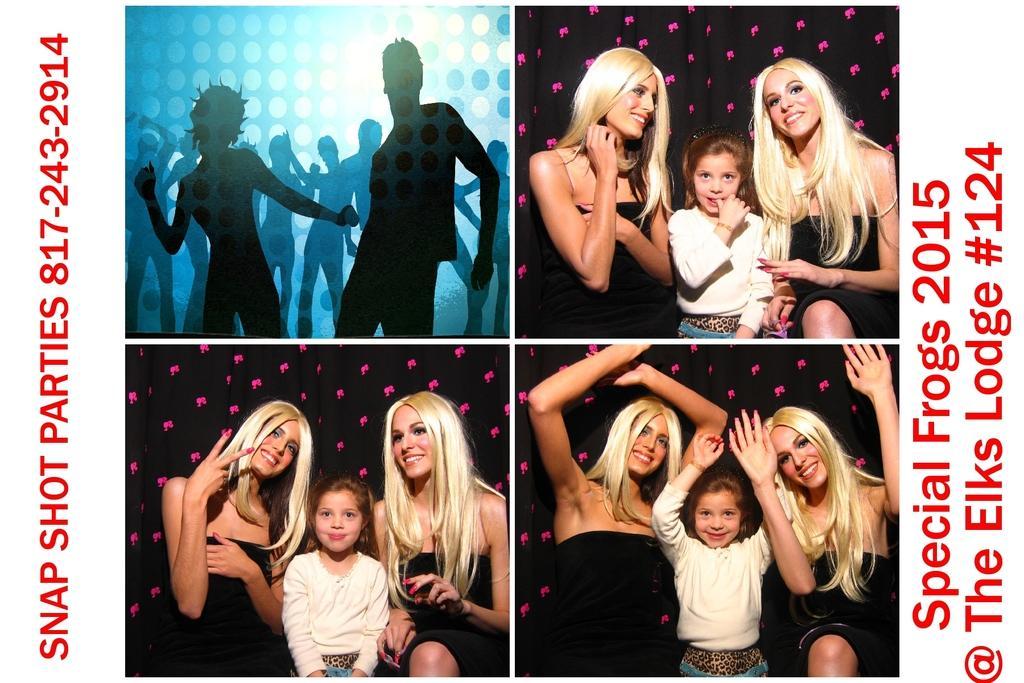Could you give a brief overview of what you see in this image? This is a collage image of a few people with a smile on their face. On the left and right side of the image there is some text. 